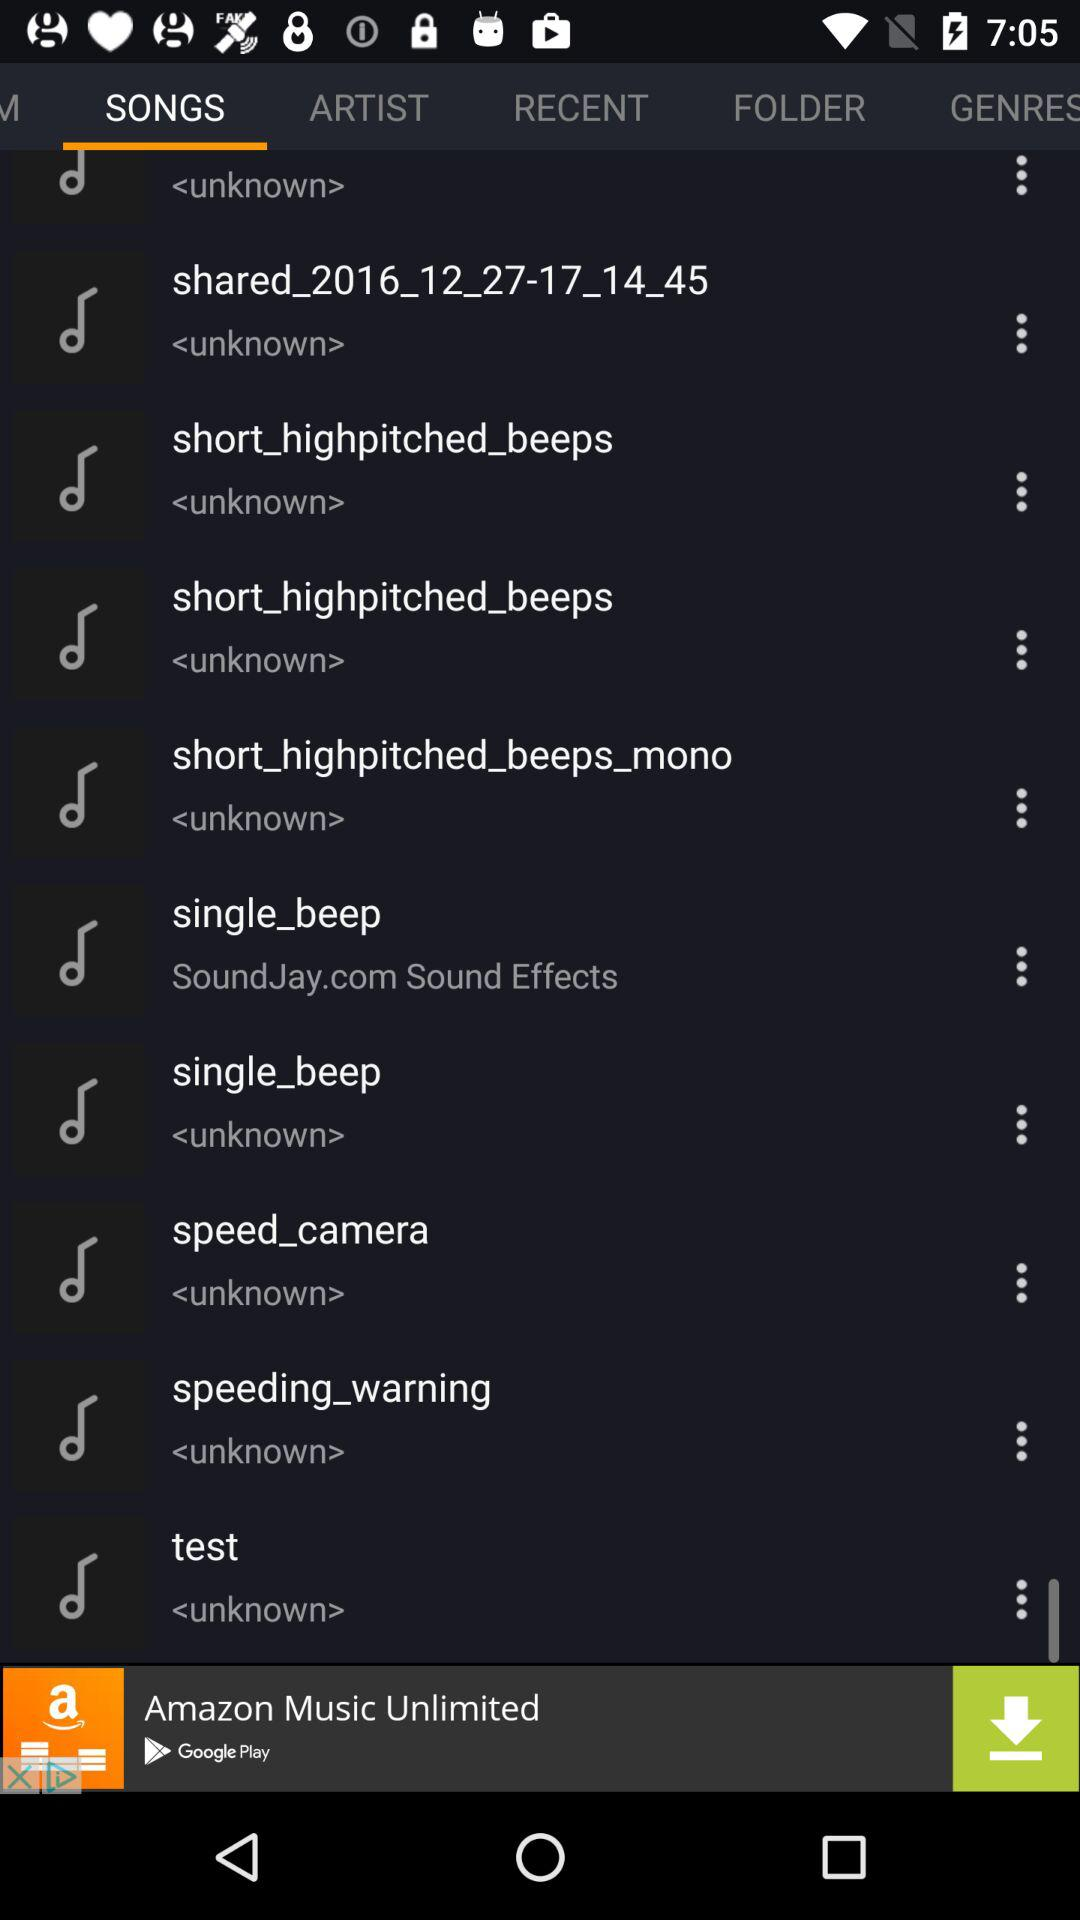Which tab has been selected? The selected tab is "SONGS". 